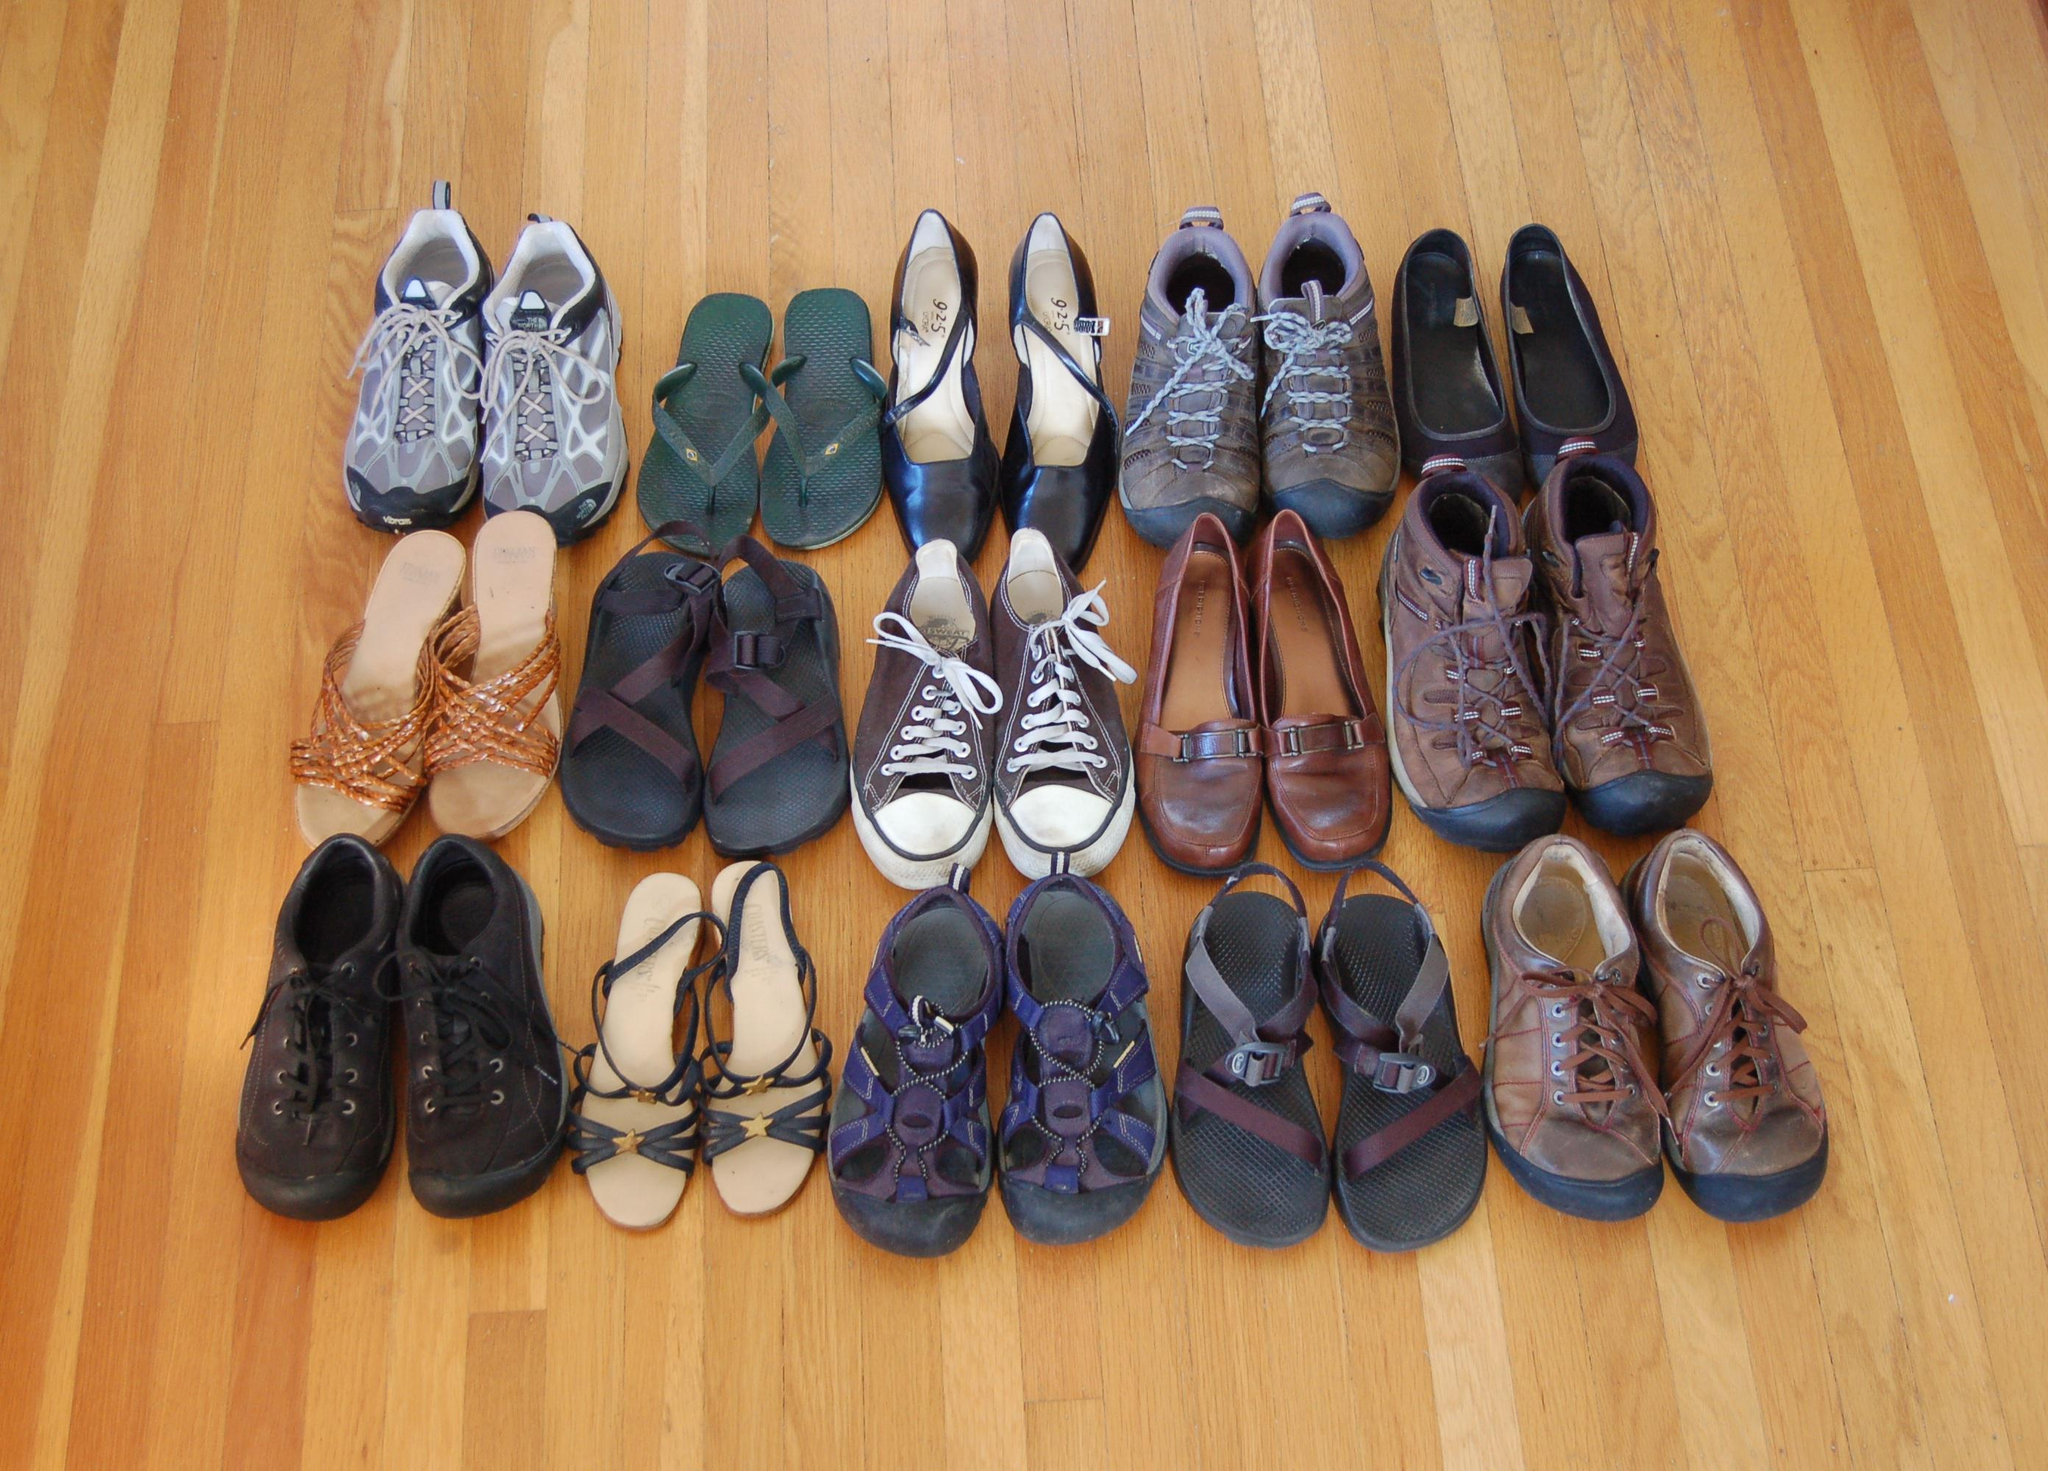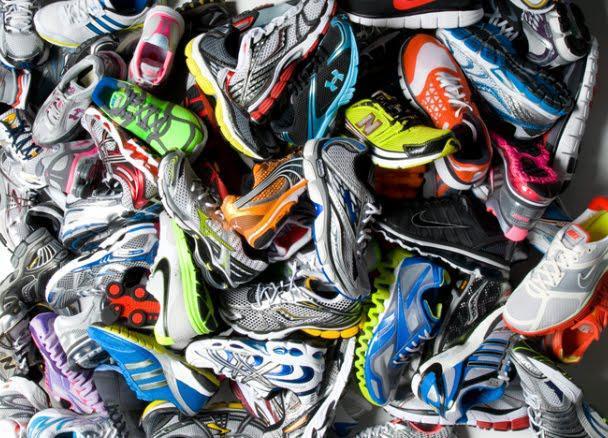The first image is the image on the left, the second image is the image on the right. Evaluate the accuracy of this statement regarding the images: "There are fifteen pairs of shoes in the left image.". Is it true? Answer yes or no. Yes. The first image is the image on the left, the second image is the image on the right. Evaluate the accuracy of this statement regarding the images: "The left image shows at least a dozen shoe pairs arranged on a wood floor, and the right image shows a messy pile of sneakers.". Is it true? Answer yes or no. Yes. 